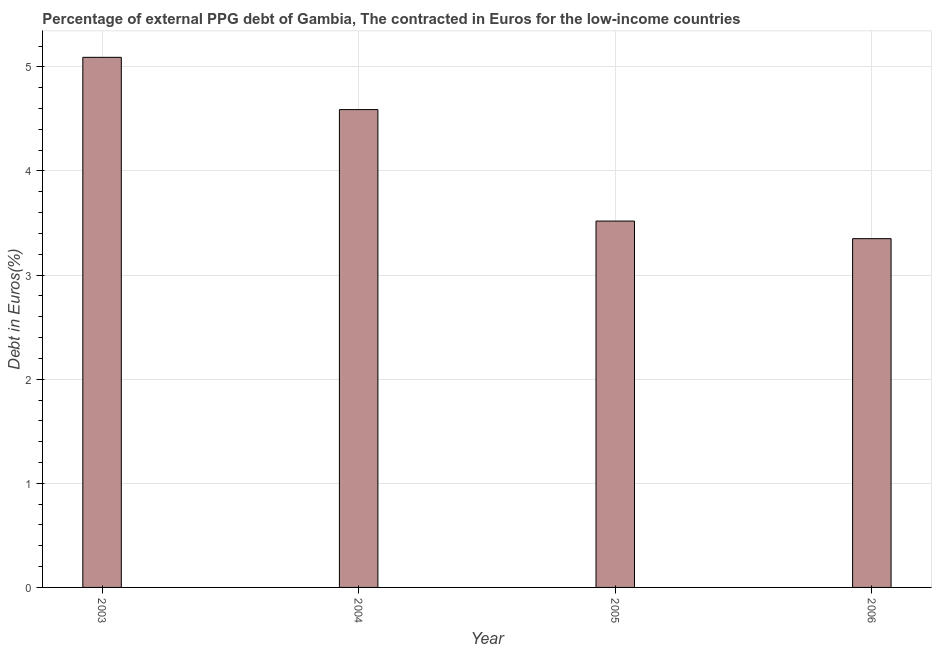What is the title of the graph?
Offer a very short reply. Percentage of external PPG debt of Gambia, The contracted in Euros for the low-income countries. What is the label or title of the Y-axis?
Give a very brief answer. Debt in Euros(%). What is the currency composition of ppg debt in 2005?
Offer a very short reply. 3.52. Across all years, what is the maximum currency composition of ppg debt?
Your response must be concise. 5.09. Across all years, what is the minimum currency composition of ppg debt?
Keep it short and to the point. 3.35. What is the sum of the currency composition of ppg debt?
Your response must be concise. 16.55. What is the difference between the currency composition of ppg debt in 2003 and 2004?
Your answer should be compact. 0.5. What is the average currency composition of ppg debt per year?
Give a very brief answer. 4.14. What is the median currency composition of ppg debt?
Provide a short and direct response. 4.05. What is the ratio of the currency composition of ppg debt in 2003 to that in 2004?
Offer a terse response. 1.11. What is the difference between the highest and the second highest currency composition of ppg debt?
Keep it short and to the point. 0.5. What is the difference between the highest and the lowest currency composition of ppg debt?
Provide a short and direct response. 1.74. In how many years, is the currency composition of ppg debt greater than the average currency composition of ppg debt taken over all years?
Provide a succinct answer. 2. How many years are there in the graph?
Ensure brevity in your answer.  4. What is the difference between two consecutive major ticks on the Y-axis?
Your answer should be very brief. 1. What is the Debt in Euros(%) of 2003?
Provide a short and direct response. 5.09. What is the Debt in Euros(%) in 2004?
Your response must be concise. 4.59. What is the Debt in Euros(%) of 2005?
Give a very brief answer. 3.52. What is the Debt in Euros(%) of 2006?
Your answer should be very brief. 3.35. What is the difference between the Debt in Euros(%) in 2003 and 2004?
Make the answer very short. 0.5. What is the difference between the Debt in Euros(%) in 2003 and 2005?
Your response must be concise. 1.57. What is the difference between the Debt in Euros(%) in 2003 and 2006?
Your response must be concise. 1.74. What is the difference between the Debt in Euros(%) in 2004 and 2005?
Keep it short and to the point. 1.07. What is the difference between the Debt in Euros(%) in 2004 and 2006?
Offer a very short reply. 1.24. What is the difference between the Debt in Euros(%) in 2005 and 2006?
Make the answer very short. 0.17. What is the ratio of the Debt in Euros(%) in 2003 to that in 2004?
Provide a short and direct response. 1.11. What is the ratio of the Debt in Euros(%) in 2003 to that in 2005?
Your answer should be very brief. 1.45. What is the ratio of the Debt in Euros(%) in 2003 to that in 2006?
Provide a short and direct response. 1.52. What is the ratio of the Debt in Euros(%) in 2004 to that in 2005?
Your response must be concise. 1.3. What is the ratio of the Debt in Euros(%) in 2004 to that in 2006?
Ensure brevity in your answer.  1.37. What is the ratio of the Debt in Euros(%) in 2005 to that in 2006?
Provide a short and direct response. 1.05. 